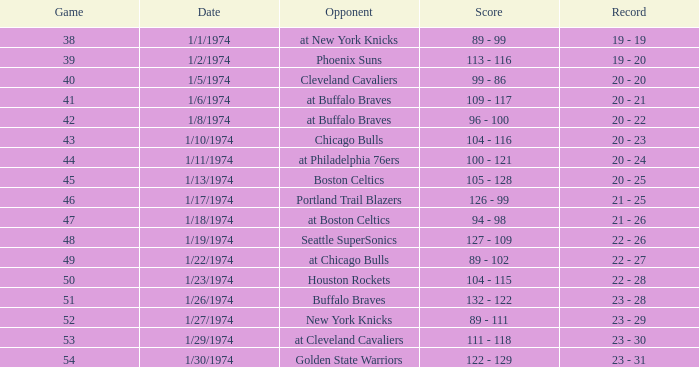What was the standing after the 51st game on january 27, 1974? 23 - 29. 